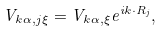Convert formula to latex. <formula><loc_0><loc_0><loc_500><loc_500>V _ { { k } \alpha , j \xi } = V _ { { k } \alpha , \xi } e ^ { i { k } \cdot { R } _ { j } } ,</formula> 